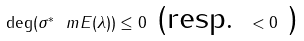Convert formula to latex. <formula><loc_0><loc_0><loc_500><loc_500>\deg ( \sigma ^ { * } \ m E ( \lambda ) ) \leq 0 \text { (resp. } < 0 \text { ) }</formula> 